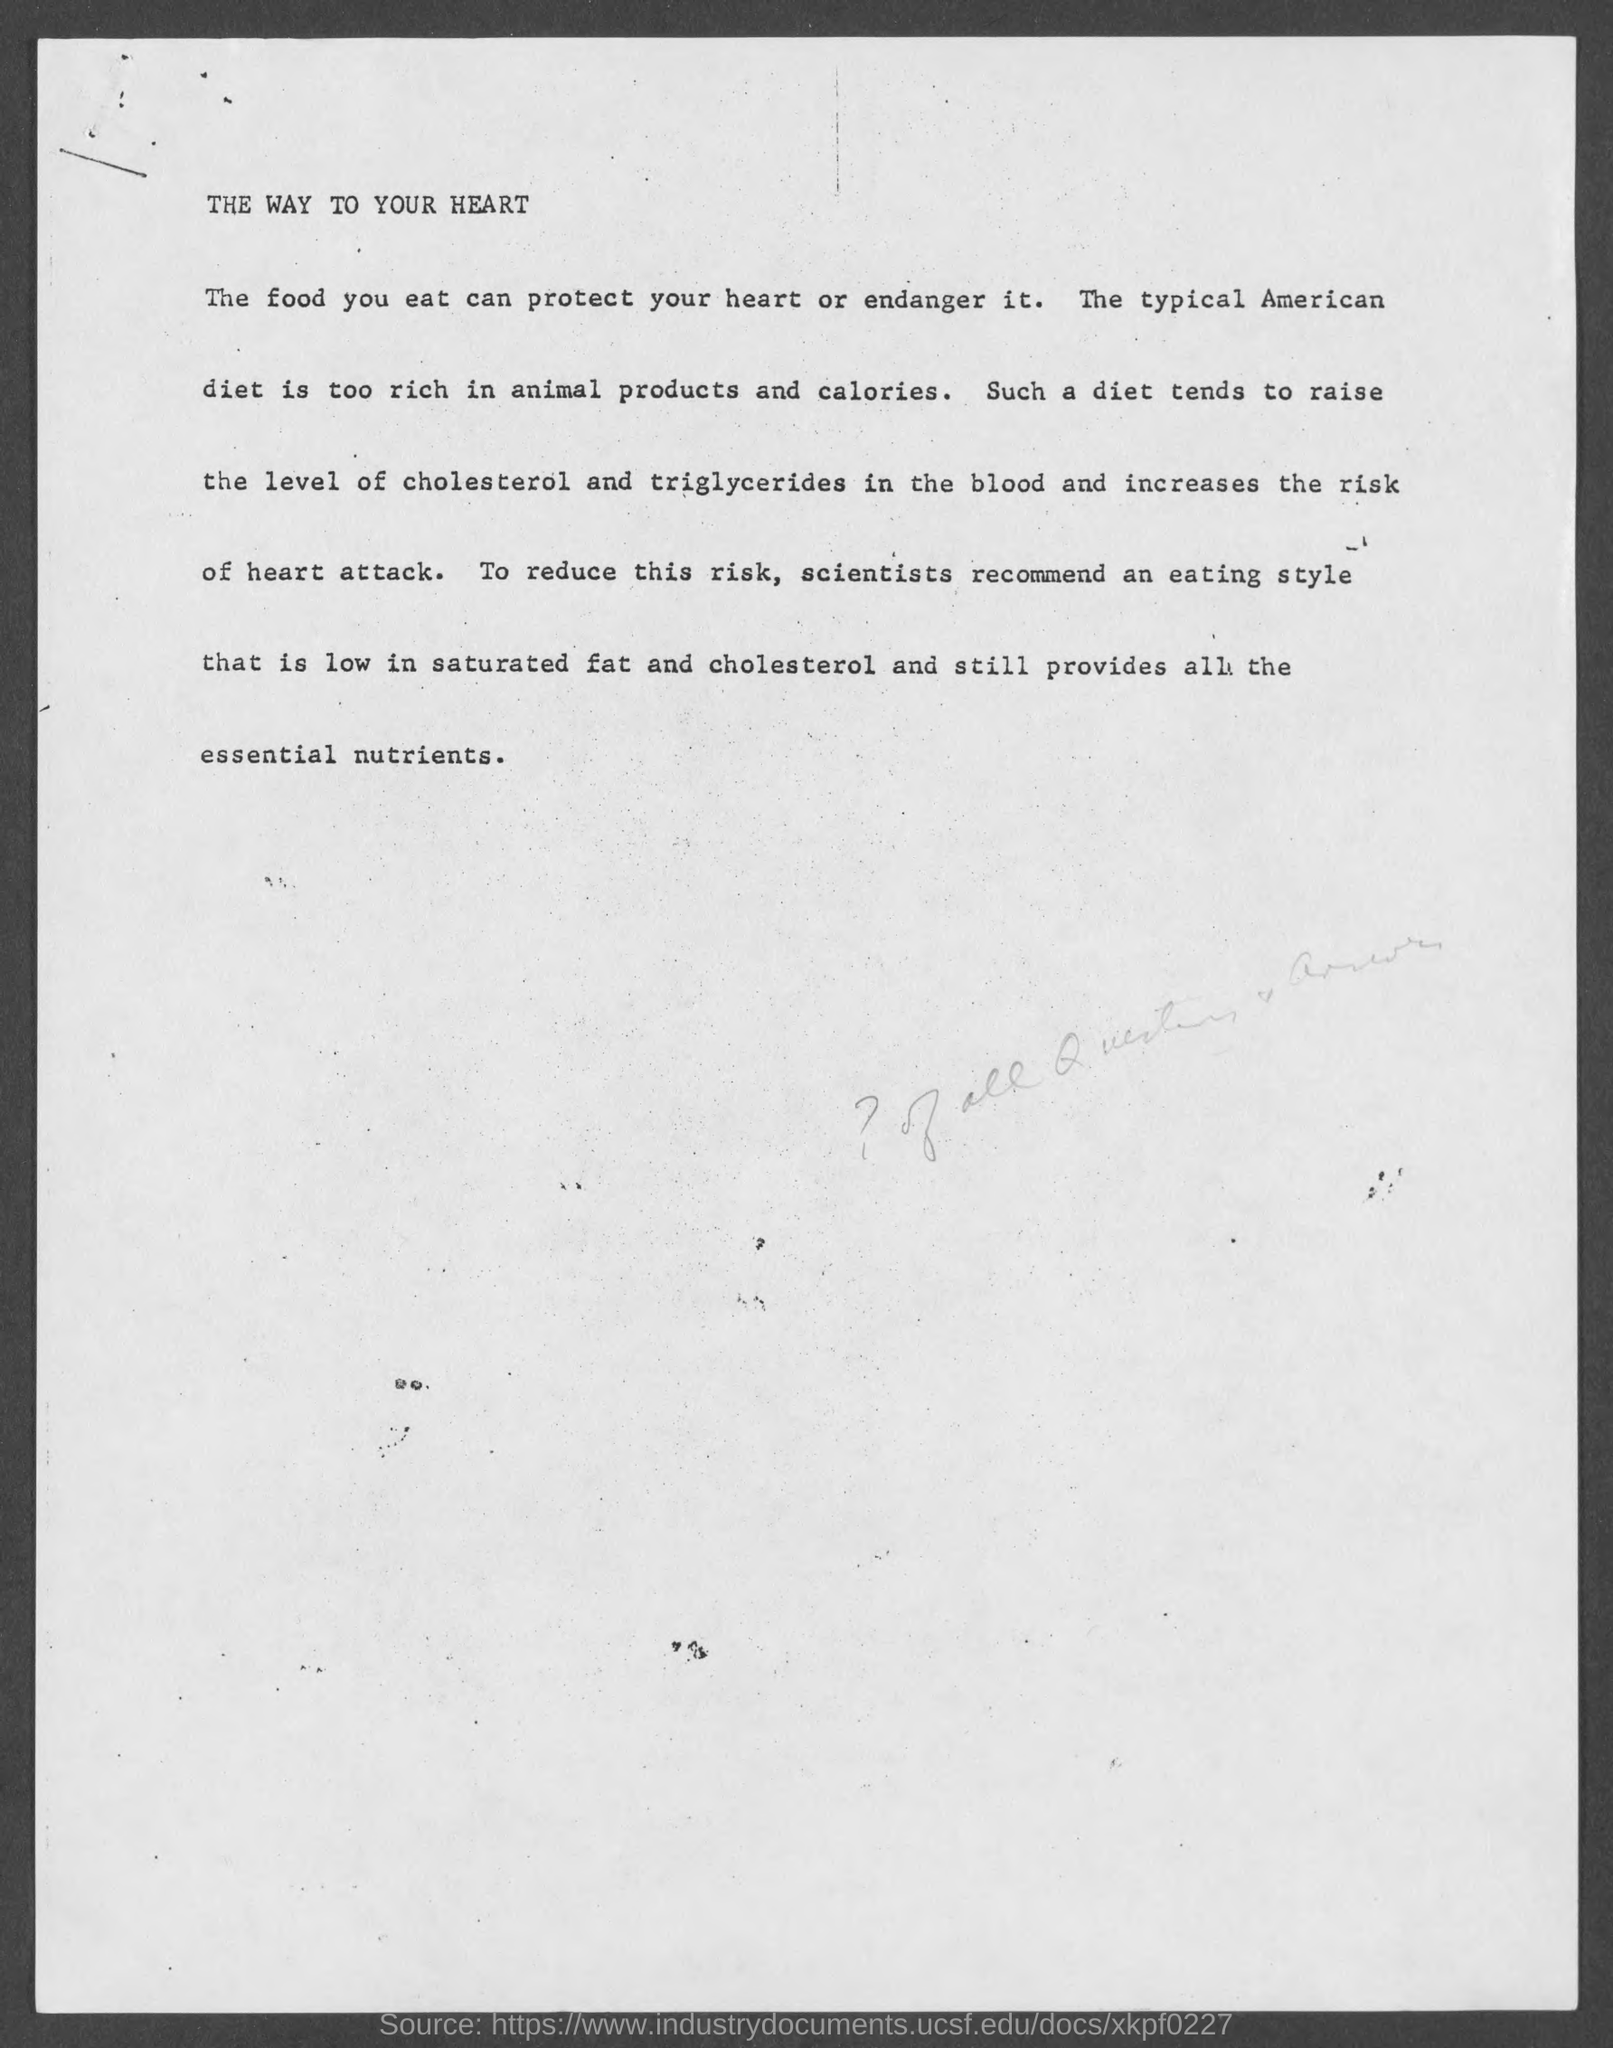Point out several critical features in this image. The document is titled "The Way to Your Heart. 